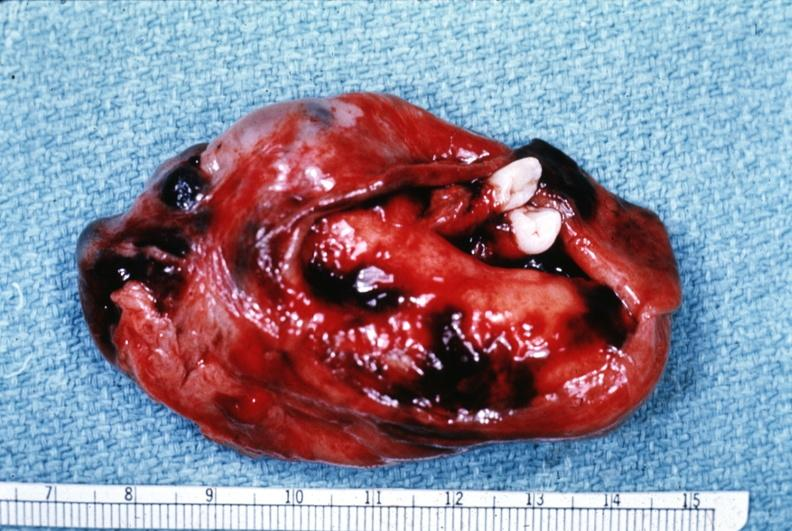what is present?
Answer the question using a single word or phrase. Female reproductive 